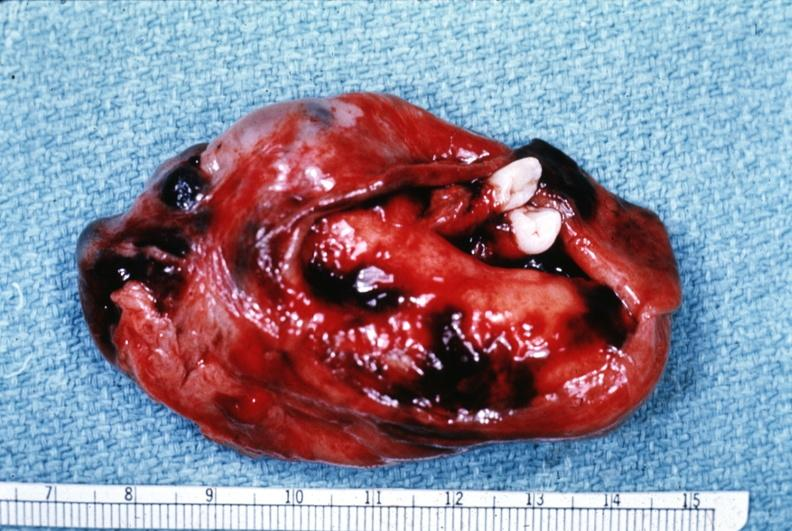what is present?
Answer the question using a single word or phrase. Female reproductive 